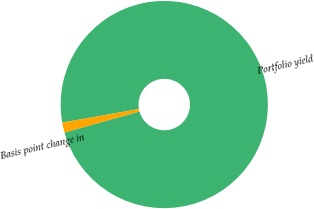Convert chart. <chart><loc_0><loc_0><loc_500><loc_500><pie_chart><fcel>Portfolio yield<fcel>Basis point change in<nl><fcel>98.44%<fcel>1.56%<nl></chart> 